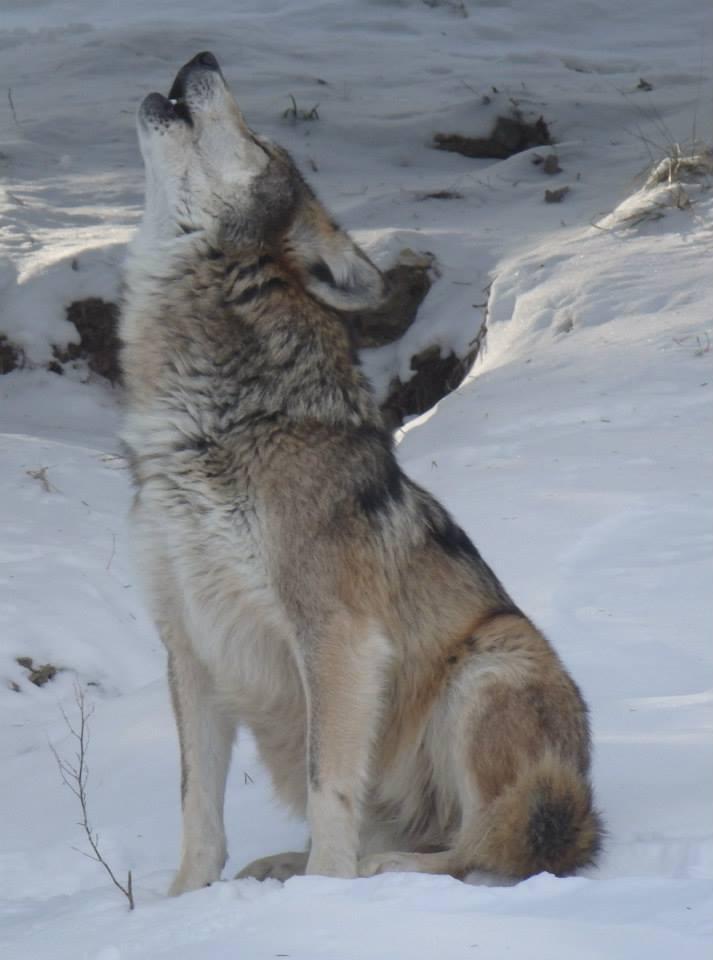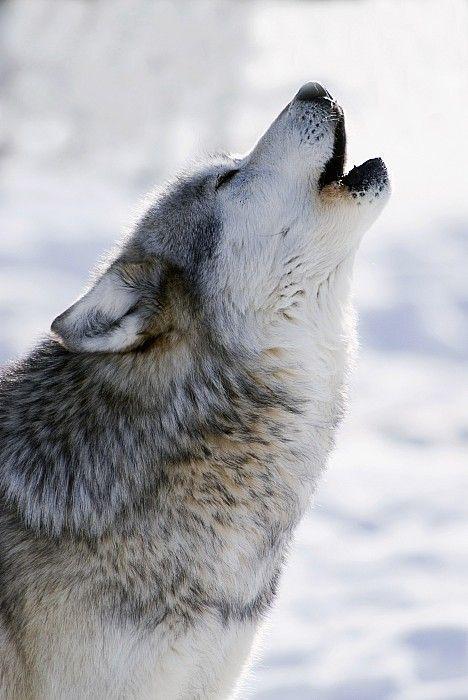The first image is the image on the left, the second image is the image on the right. Evaluate the accuracy of this statement regarding the images: "Each dog is howling in the snow.". Is it true? Answer yes or no. Yes. The first image is the image on the left, the second image is the image on the right. Examine the images to the left and right. Is the description "All wolves are howling, all scenes contain snow, and no image contains more than one wolf." accurate? Answer yes or no. Yes. 